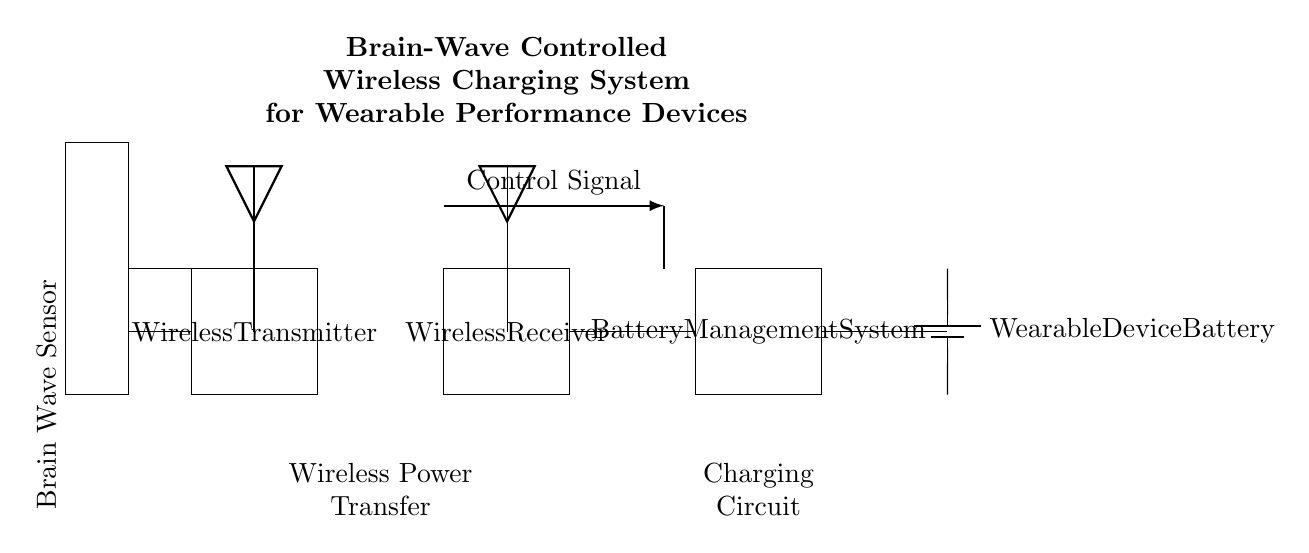What does the leftmost component represent? The leftmost component is labeled as the "Brain Wave Sensor," which indicates it is responsible for detecting brain waves.
Answer: Brain Wave Sensor What does the antenna symbolize? The antenna is part of both the wireless transmitter and receiver, indicating they are responsible for wireless communication in the system.
Answer: Wireless communication How many main components are shown in the diagram? By counting the distinct labeled components, there are five main components: the brain wave sensor, wireless transmitter, wireless receiver, battery management system, and wearable device battery.
Answer: Five What is the purpose of the battery management system? The battery management system regulates and manages the charge and discharge cycles of the wearable device's battery, ensuring optimal performance and safety.
Answer: Battery management What does the control signal connect? The control signal connects the wireless receiver to the battery management system, which implies it is used to relay instructions on how to handle the charge process.
Answer: Wireless receiver to battery management system What type of power transfer is depicted? The circuit depicts wireless power transfer, which allows energy to be sent from the transmitter to the receiver without physical connectors, allowing for flexibility in use.
Answer: Wireless power transfer List the transfer method used for powering the wearable device. The method of powering the wearable device is through wireless transfer from the wireless receiver to its battery, as indicated by the connections in the circuit.
Answer: Wireless transfer 